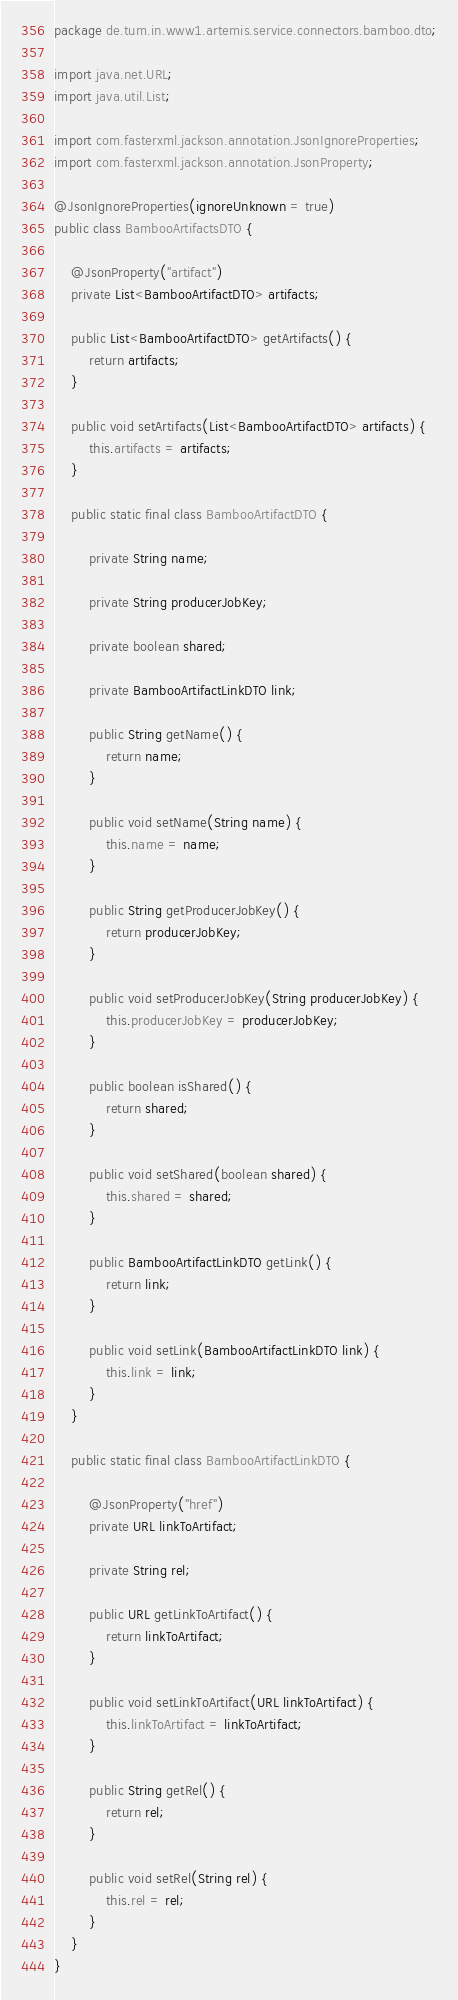Convert code to text. <code><loc_0><loc_0><loc_500><loc_500><_Java_>package de.tum.in.www1.artemis.service.connectors.bamboo.dto;

import java.net.URL;
import java.util.List;

import com.fasterxml.jackson.annotation.JsonIgnoreProperties;
import com.fasterxml.jackson.annotation.JsonProperty;

@JsonIgnoreProperties(ignoreUnknown = true)
public class BambooArtifactsDTO {

    @JsonProperty("artifact")
    private List<BambooArtifactDTO> artifacts;

    public List<BambooArtifactDTO> getArtifacts() {
        return artifacts;
    }

    public void setArtifacts(List<BambooArtifactDTO> artifacts) {
        this.artifacts = artifacts;
    }

    public static final class BambooArtifactDTO {

        private String name;

        private String producerJobKey;

        private boolean shared;

        private BambooArtifactLinkDTO link;

        public String getName() {
            return name;
        }

        public void setName(String name) {
            this.name = name;
        }

        public String getProducerJobKey() {
            return producerJobKey;
        }

        public void setProducerJobKey(String producerJobKey) {
            this.producerJobKey = producerJobKey;
        }

        public boolean isShared() {
            return shared;
        }

        public void setShared(boolean shared) {
            this.shared = shared;
        }

        public BambooArtifactLinkDTO getLink() {
            return link;
        }

        public void setLink(BambooArtifactLinkDTO link) {
            this.link = link;
        }
    }

    public static final class BambooArtifactLinkDTO {

        @JsonProperty("href")
        private URL linkToArtifact;

        private String rel;

        public URL getLinkToArtifact() {
            return linkToArtifact;
        }

        public void setLinkToArtifact(URL linkToArtifact) {
            this.linkToArtifact = linkToArtifact;
        }

        public String getRel() {
            return rel;
        }

        public void setRel(String rel) {
            this.rel = rel;
        }
    }
}
</code> 